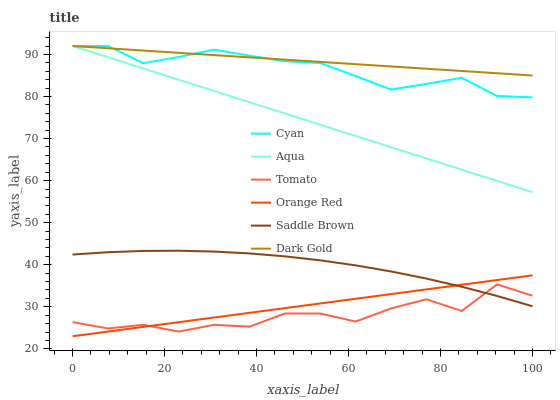Does Tomato have the minimum area under the curve?
Answer yes or no. Yes. Does Dark Gold have the maximum area under the curve?
Answer yes or no. Yes. Does Aqua have the minimum area under the curve?
Answer yes or no. No. Does Aqua have the maximum area under the curve?
Answer yes or no. No. Is Orange Red the smoothest?
Answer yes or no. Yes. Is Tomato the roughest?
Answer yes or no. Yes. Is Dark Gold the smoothest?
Answer yes or no. No. Is Dark Gold the roughest?
Answer yes or no. No. Does Orange Red have the lowest value?
Answer yes or no. Yes. Does Aqua have the lowest value?
Answer yes or no. No. Does Cyan have the highest value?
Answer yes or no. Yes. Does Saddle Brown have the highest value?
Answer yes or no. No. Is Orange Red less than Dark Gold?
Answer yes or no. Yes. Is Aqua greater than Saddle Brown?
Answer yes or no. Yes. Does Tomato intersect Saddle Brown?
Answer yes or no. Yes. Is Tomato less than Saddle Brown?
Answer yes or no. No. Is Tomato greater than Saddle Brown?
Answer yes or no. No. Does Orange Red intersect Dark Gold?
Answer yes or no. No. 